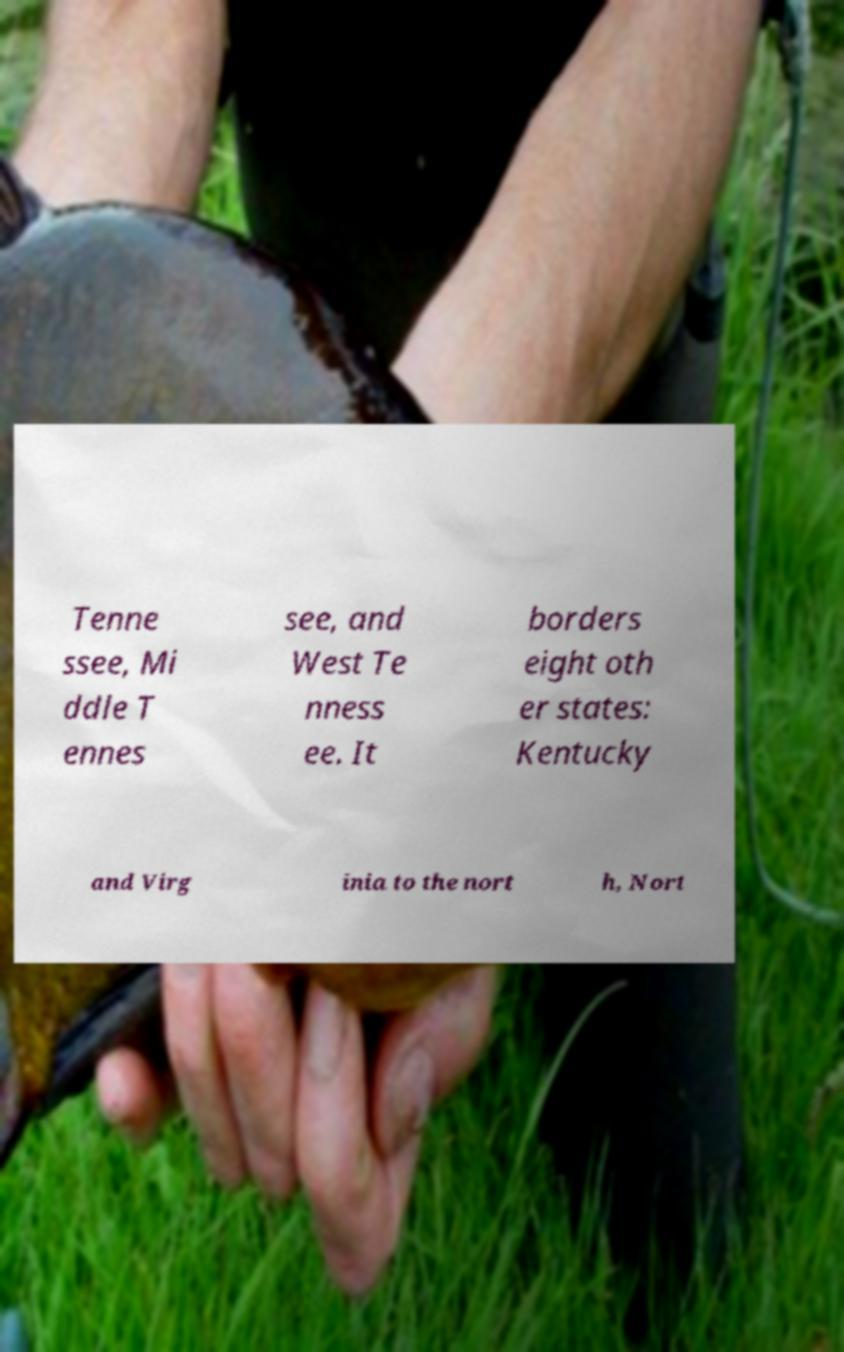Please identify and transcribe the text found in this image. Tenne ssee, Mi ddle T ennes see, and West Te nness ee. It borders eight oth er states: Kentucky and Virg inia to the nort h, Nort 